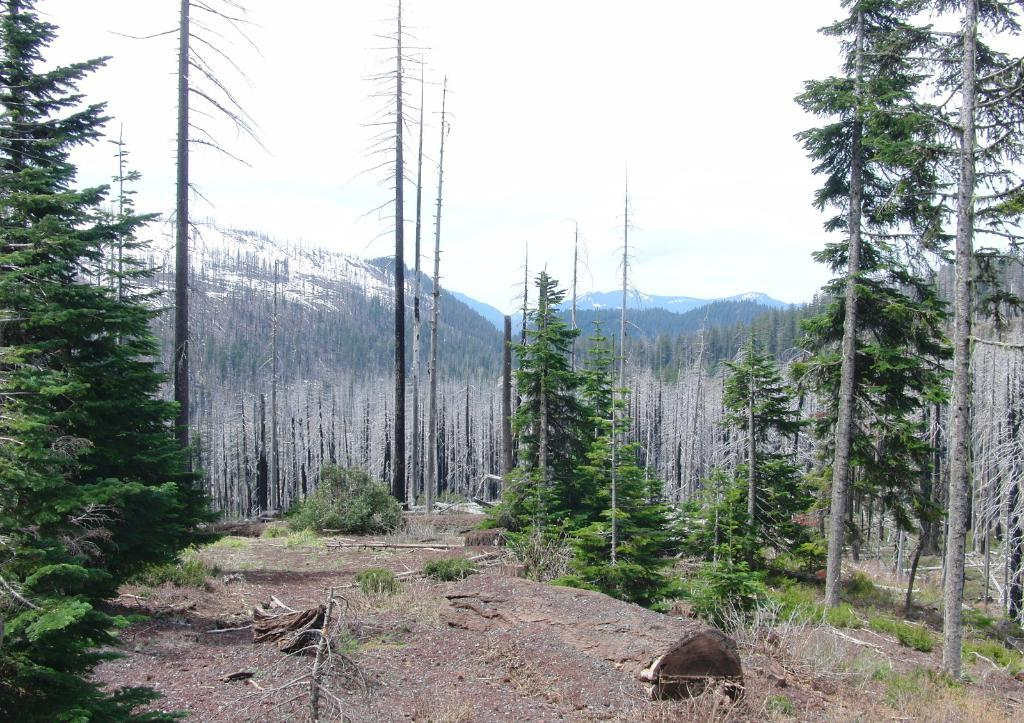What type of vegetation can be seen in the image? There are trees and plants in the image. What is visible in the sky in the image? The sky is visible in the image. What type of landscape feature is visible in the background of the image? There are mountains in the background of the image. What else can be seen in the background of the image? There are other objects in the background of the image. What type of acoustics can be heard from the ants in the image? There are no ants present in the image, and therefore no acoustics can be heard from them. What type of home is visible in the image? There is no home visible in the image; it primarily features natural elements such as trees, plants, and mountains. 